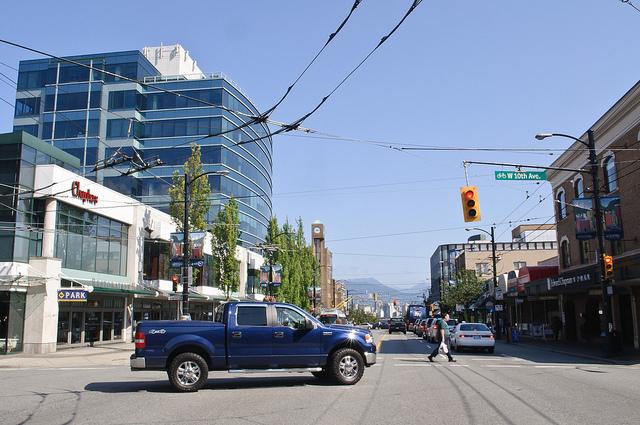What might happen if the blue truck turns left too fast?
Keep it brief. Hit pedestrian. What color is the traffic signal?
Concise answer only. Red. What color is the light?
Concise answer only. Red. Is this a food truck?
Concise answer only. No. Is it a warm day?
Keep it brief. Yes. What road are they crossing at this intersection?
Give a very brief answer. W 10th ave. Are these city busses?
Quick response, please. No. Is it morning or evening in the picture?
Short answer required. Morning. Is this a color photo?
Give a very brief answer. Yes. Is the person going to get hit?
Concise answer only. No. 